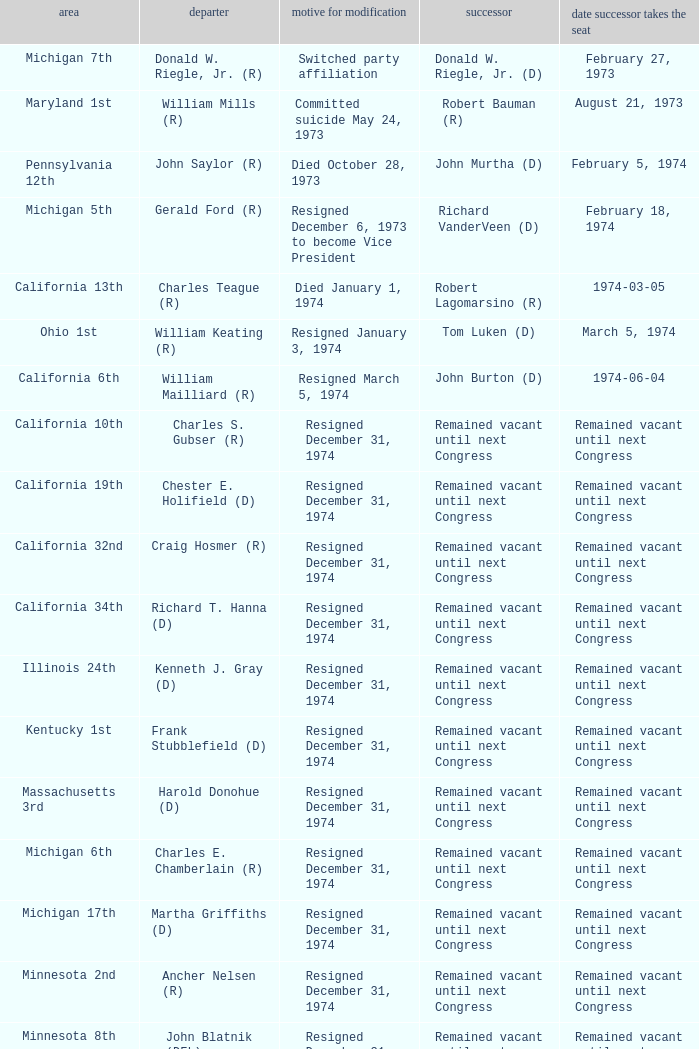When was the successor seated when the district was California 10th? Remained vacant until next Congress. 